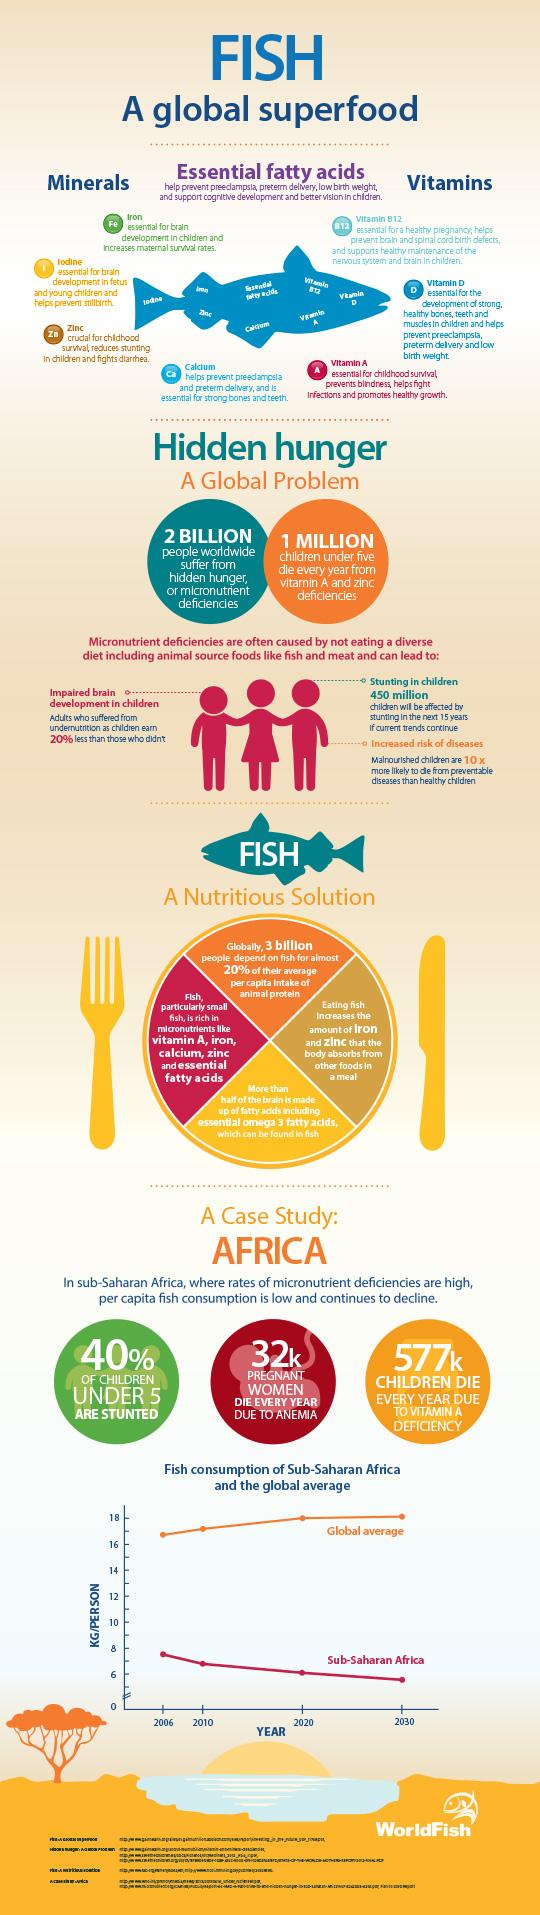Give some essential details in this illustration. There are four essential minerals found in fish, according to research. Fish is a rich source of several essential vitamins, including vitamins A, D, and B12. According to estimates, over 1 billion children globally suffer from Vitamin A deficiencies. 